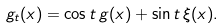<formula> <loc_0><loc_0><loc_500><loc_500>g _ { t } ( x ) = \cos t \, g ( x ) + \sin t \, \xi ( x ) .</formula> 